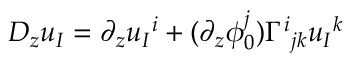<formula> <loc_0><loc_0><loc_500><loc_500>D _ { z } u _ { I } = \partial _ { z } u _ { I ^ { i } + ( \partial _ { z } \phi _ { 0 } ^ { j } ) \Gamma ^ { i _ { j k } u _ { I ^ { k }</formula> 